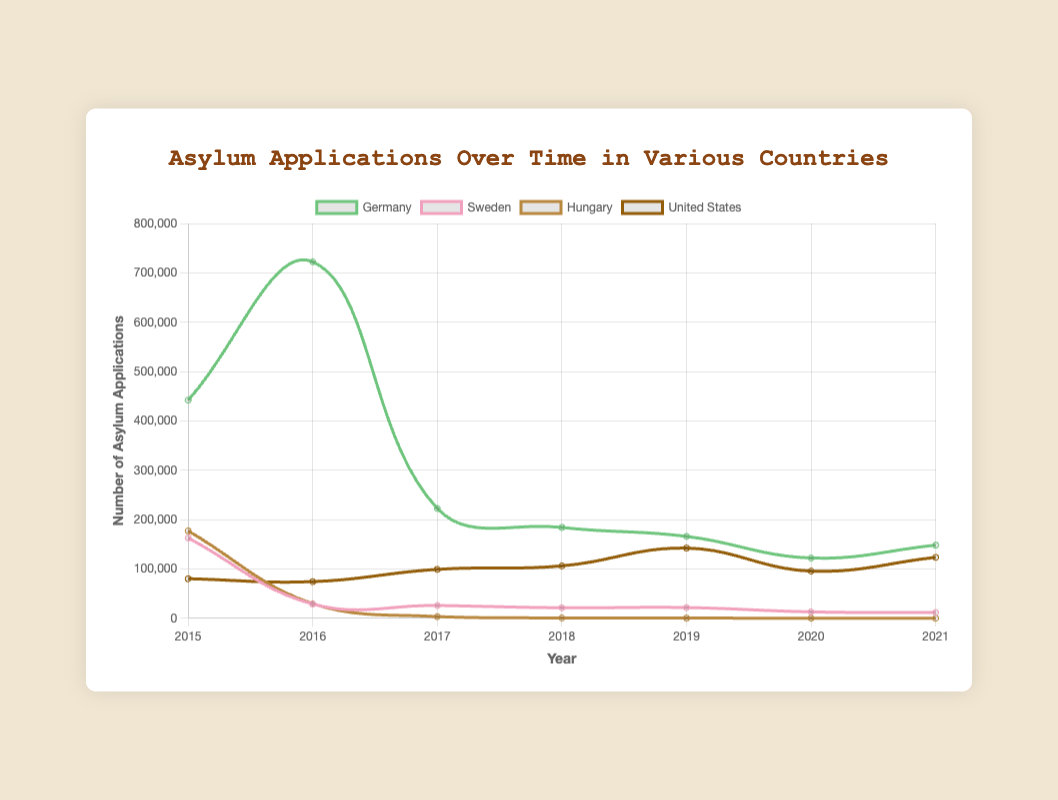What is the trend of asylum applications in Germany from 2015 to 2021? To determine the trend, look at the line representing Germany's asylum applications over the years. In 2015, the applications start at 441,899 and peak in 2016 at 722,370. After 2016, there is a sharp decline, progressively decreasing each year, with slight fluctuations, reaching 148,233 in 2021.
Answer: Decreasing Which country had the highest number of asylum applications in 2015? To find the answer, look for the country whose line reaches the highest point on the graph in the year 2015. Comparing the values for the year 2015, the highest point is for Germany with 441,899 asylum applications.
Answer: Germany What was the combined number of asylum applications in Germany and Sweden in 2016? Add the asylum applications for Germany and Sweden in 2016. Germany had 722,370 applications, and Sweden had 28,866. The combined number is 722,370 + 28,866 = 751,236.
Answer: 751,236 How did the number of asylum applications in the United States change from 2019 to 2020? Look at the line for the United States and compare the values in 2019 and 2020. In 2019, there were 142,299 applications, and in 2020, there were 95,579. The change is a decrease of 142,299 - 95,579 = 46,720.
Answer: Decreased by 46,720 For which country do we observe the most dramatic decline in asylum applications between 2015 and 2021? Observe the lines for each country from 2015 to 2021. The line for Hungary shows the most significant decline, starting from 177,135 in 2015 and decreasing almost to zero, with 38 applications in 2021.
Answer: Hungary In which year did asylum applications in Germany see the largest drop, and what was the difference from the previous year? Examine the values for Germany year by year to determine the largest decrease. Between 2016 and 2017, the applications dropped from 722,370 to 222,560, a difference of 722,370 - 222,560 = 499,810.
Answer: 2017; 499,810 Which country had the fewest asylum applications in 2018, and how many were there? Find the country with the lowest point on the graph in 2018. Hungary had 671 asylum applications, the lowest among the compared countries.
Answer: Hungary; 671 What is the average number of asylum applications in Sweden over the years 2015 to 2021? Add the number of asylum applications in Sweden from 2015 to 2021, then divide by the number of years. (162,877 + 28,866 + 25,939 + 21,302 + 21,760 + 13,000 + 11,660) / 7 = 283,404 / 7 = 40,486.
Answer: 40,486 In 2021, how does the number of asylum applications in the United States compare to that in Germany? Look at the points for the year 2021 for both countries. The United States had 123,510 applications, and Germany had 148,233. 123,510 is less than 148,233.
Answer: Less What is the overall trend in the asylum applications for Sweden from 2015 to 2021? Observe the line for Sweden from 2015 to 2021. Starting in 2015 with 162,877, there is a noticeable decline over the years, reaching the lowest point in 2021 with 11,660.
Answer: Decreasing 